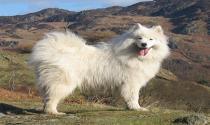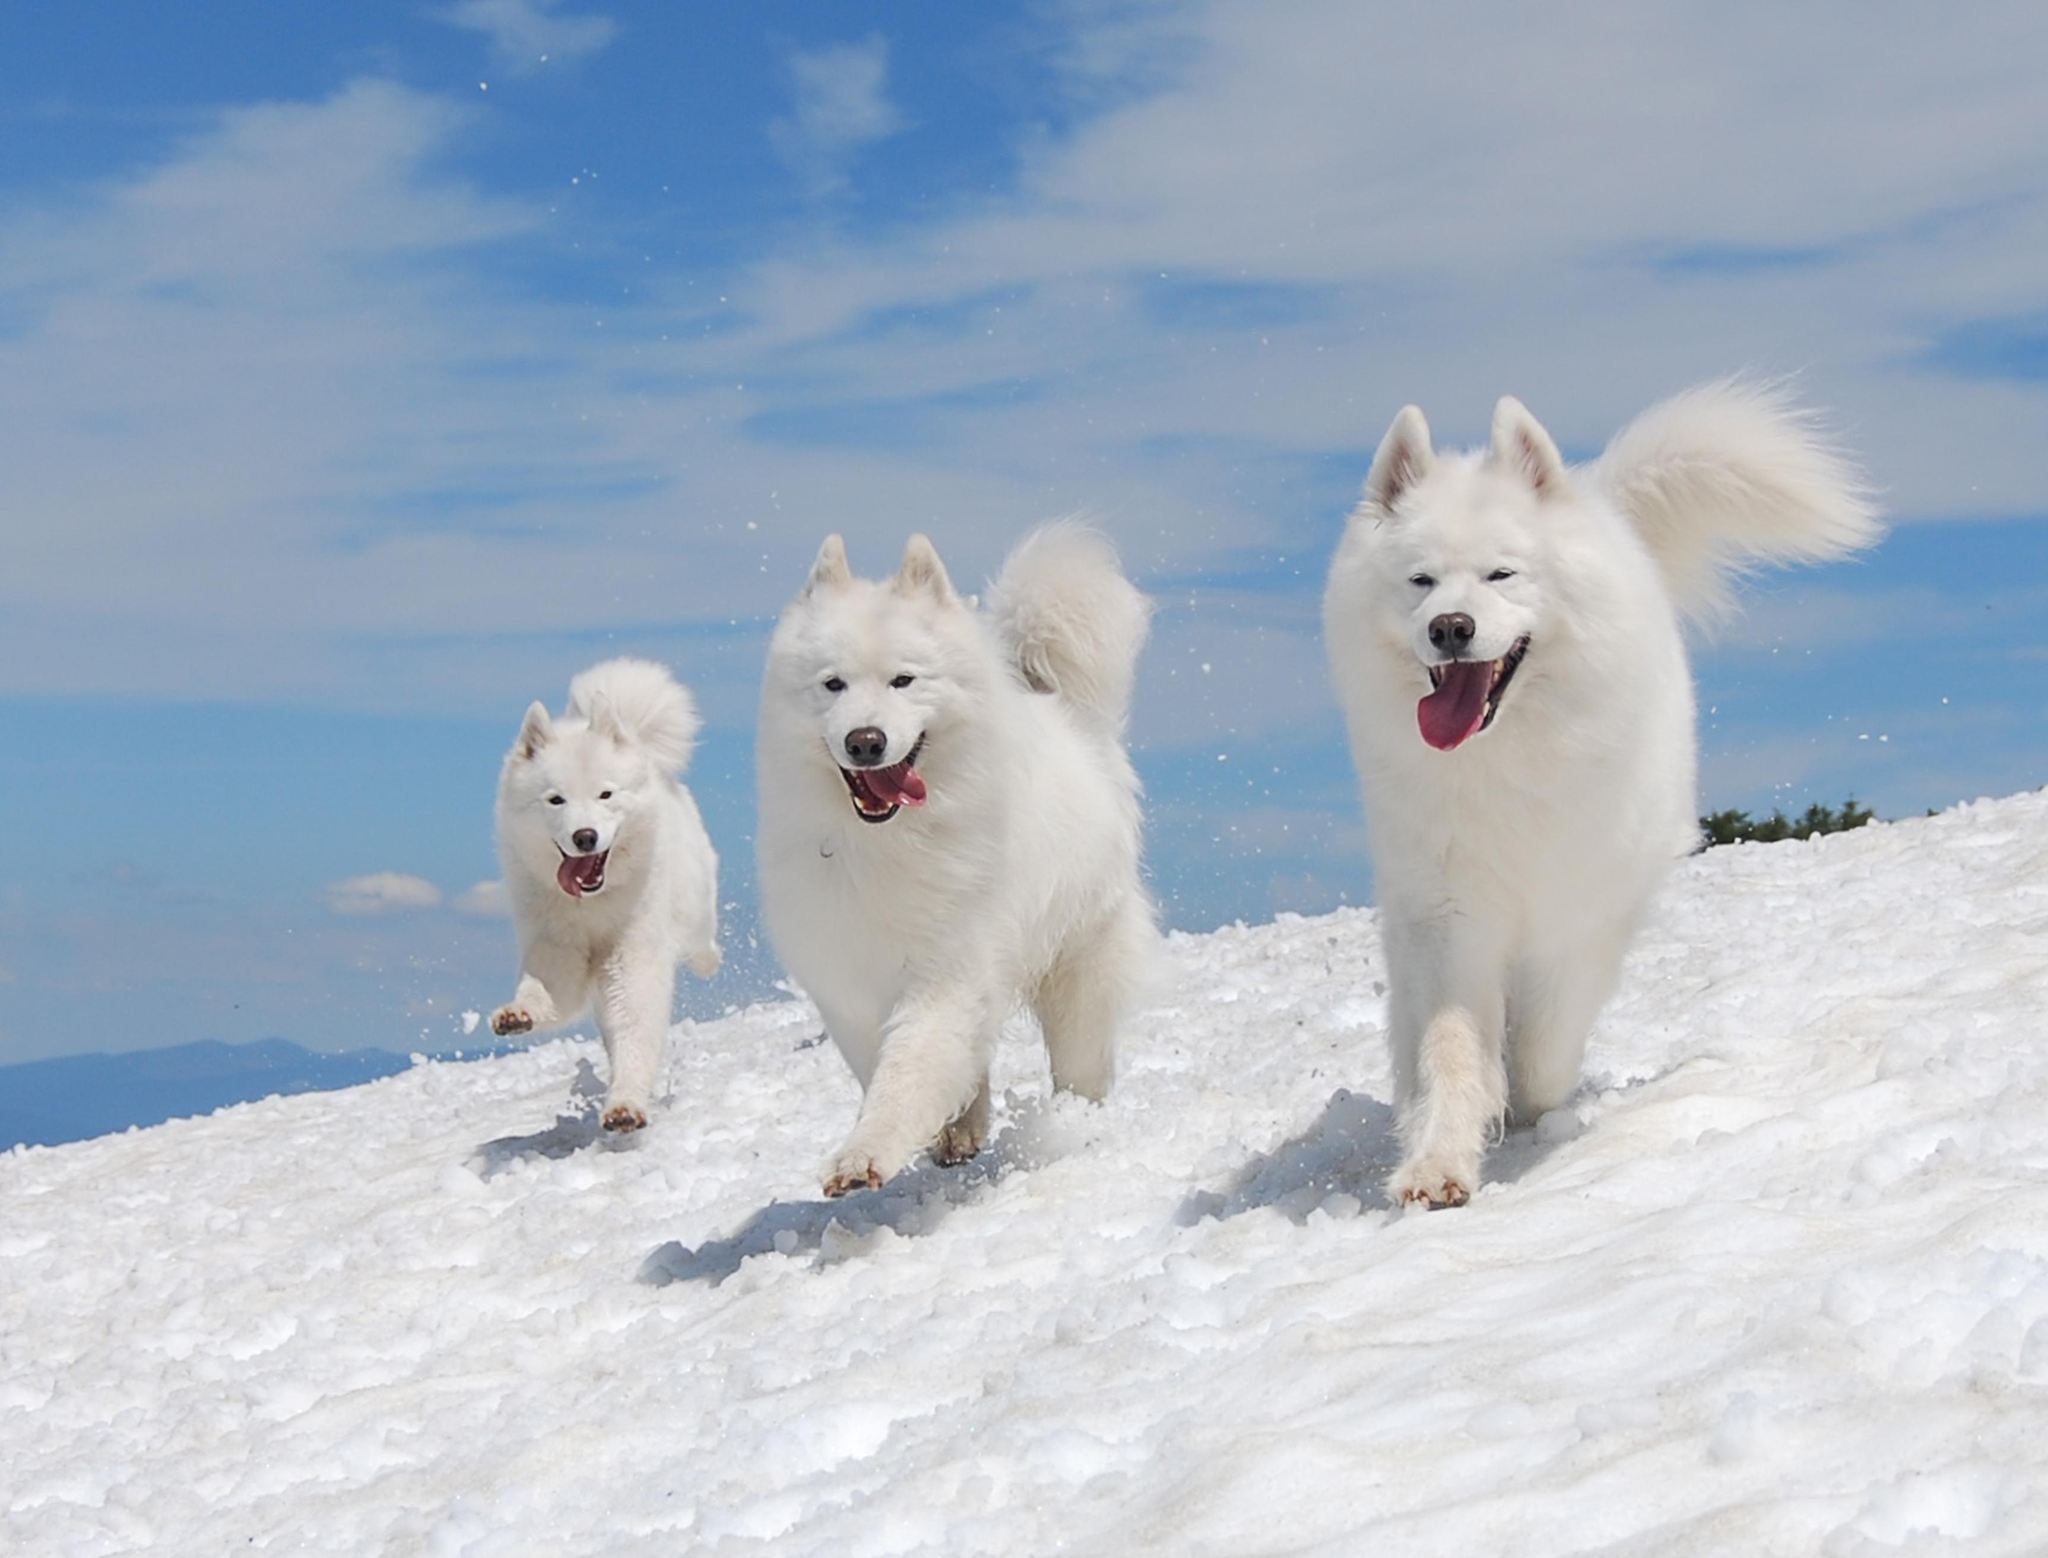The first image is the image on the left, the second image is the image on the right. For the images shown, is this caption "At least one dog is in the snow." true? Answer yes or no. Yes. The first image is the image on the left, the second image is the image on the right. Considering the images on both sides, is "there is at least one dog stading in the snow in the image pair" valid? Answer yes or no. Yes. 